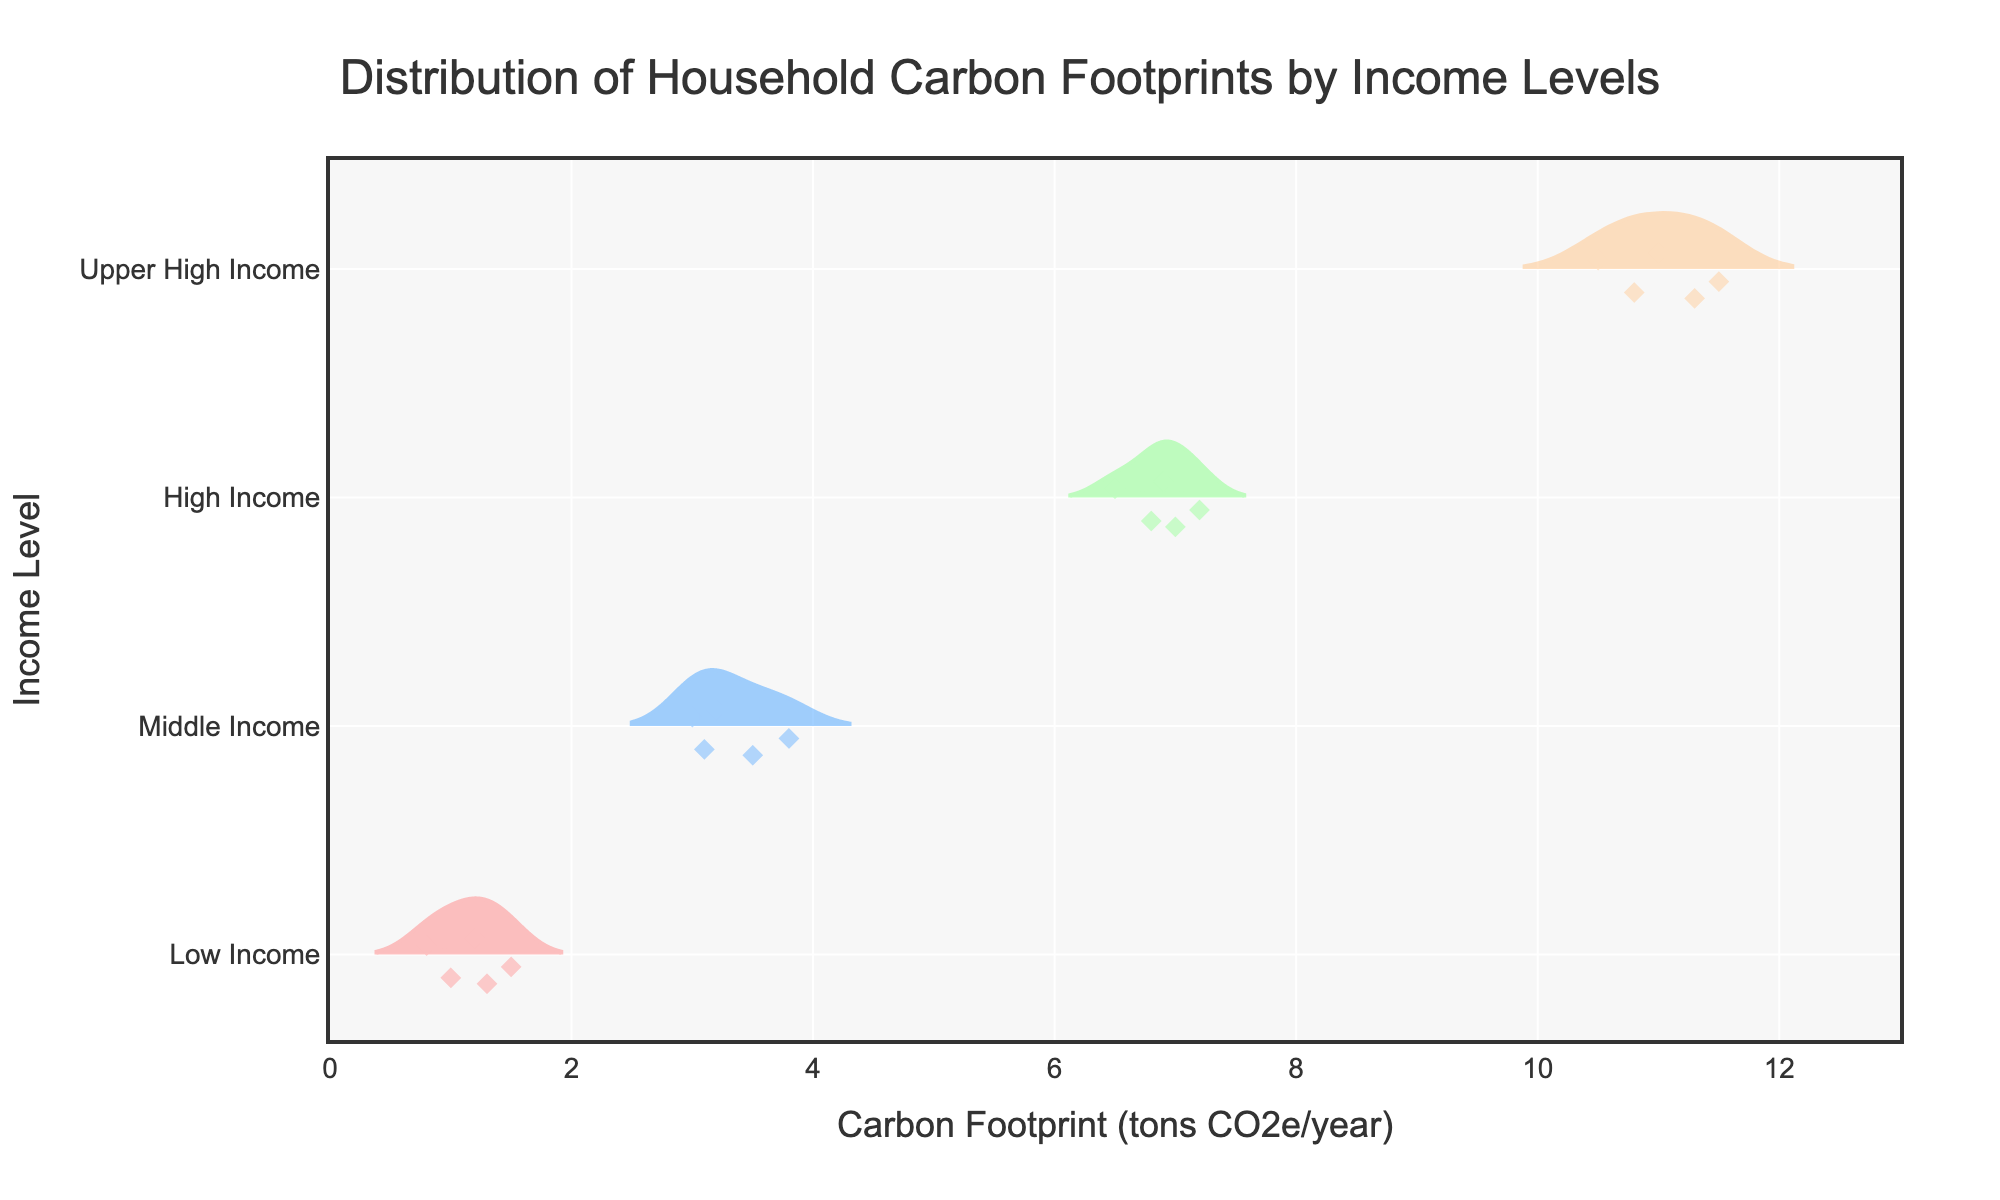What's the title of the figure? The title is located at the top of the figure and is meant to describe what the plot is illustrating.
Answer: Distribution of Household Carbon Footprints by Income Levels Which income level shows the highest carbon footprint? The carbon footprints are displayed along the x-axis, with the highest values to the right. The 'Upper High Income' group has carbon footprint values reaching around 11.0 tons CO2e/year.
Answer: Upper High Income How many data points are there for the 'Middle Income' group? Each data point corresponds to a diamond marker on the 'Middle Income' horizontal strip. By counting these diamonds, the number of data points can be determined.
Answer: 5 What is the range of carbon footprints for the 'Low Income' group? The range can be seen by looking at the span of diamond markers along the x-axis for the 'Low Income' group. The lowest value is around 0.8 and the highest value is around 1.5.
Answer: 0.7 tons CO2e/year What is the average carbon footprint for the 'High Income' group? To calculate the average, add the values and divide by the number of points: (6.5 + 7.0 + 6.8 + 7.2 + 6.9) / 5 = 34.4 / 5.
Answer: 6.88 tons CO2e/year How does the carbon footprint spread for 'High Income' compare to 'Low Income'? The spread can be assessed by comparing the range and density of the carbon footprint distributions for both groups. 'High Income' has a wider range and more spread out distribution compared to the tightly clustered 'Low Income'.
Answer: High Income has a wider spread Which group has the smallest variability in carbon footprints? Variability can be interpreted by analyzing the width and spread of the violin plots. Tighter and narrower plots indicate smaller variability.
Answer: Low Income What distinguishes the box plot elements within the violin plots? The box plot within the violin plots indicates summary statistics like median (line inside box), interquartile range (box edges), and possible outliers (individual points).
Answer: Summary statistics What's the median carbon footprint value for the 'Upper High Income' group? The median is shown by the line inside the box within the violin plot. For 'Upper High Income', this line is around 11.0 tons CO2e/year.
Answer: 11.0 tons CO2e/year 